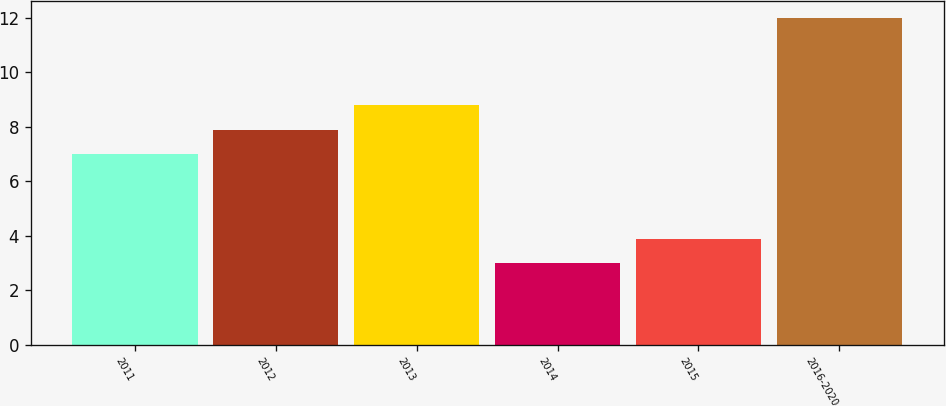<chart> <loc_0><loc_0><loc_500><loc_500><bar_chart><fcel>2011<fcel>2012<fcel>2013<fcel>2014<fcel>2015<fcel>2016-2020<nl><fcel>7<fcel>7.9<fcel>8.8<fcel>3<fcel>3.9<fcel>12<nl></chart> 